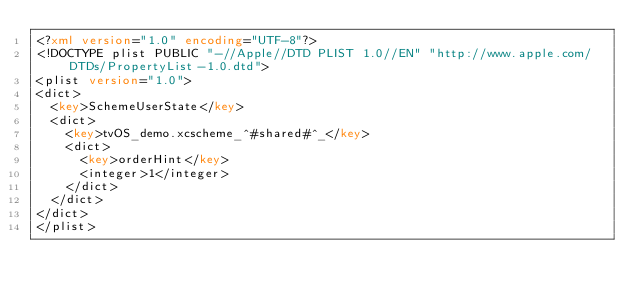Convert code to text. <code><loc_0><loc_0><loc_500><loc_500><_XML_><?xml version="1.0" encoding="UTF-8"?>
<!DOCTYPE plist PUBLIC "-//Apple//DTD PLIST 1.0//EN" "http://www.apple.com/DTDs/PropertyList-1.0.dtd">
<plist version="1.0">
<dict>
	<key>SchemeUserState</key>
	<dict>
		<key>tvOS_demo.xcscheme_^#shared#^_</key>
		<dict>
			<key>orderHint</key>
			<integer>1</integer>
		</dict>
	</dict>
</dict>
</plist>
</code> 